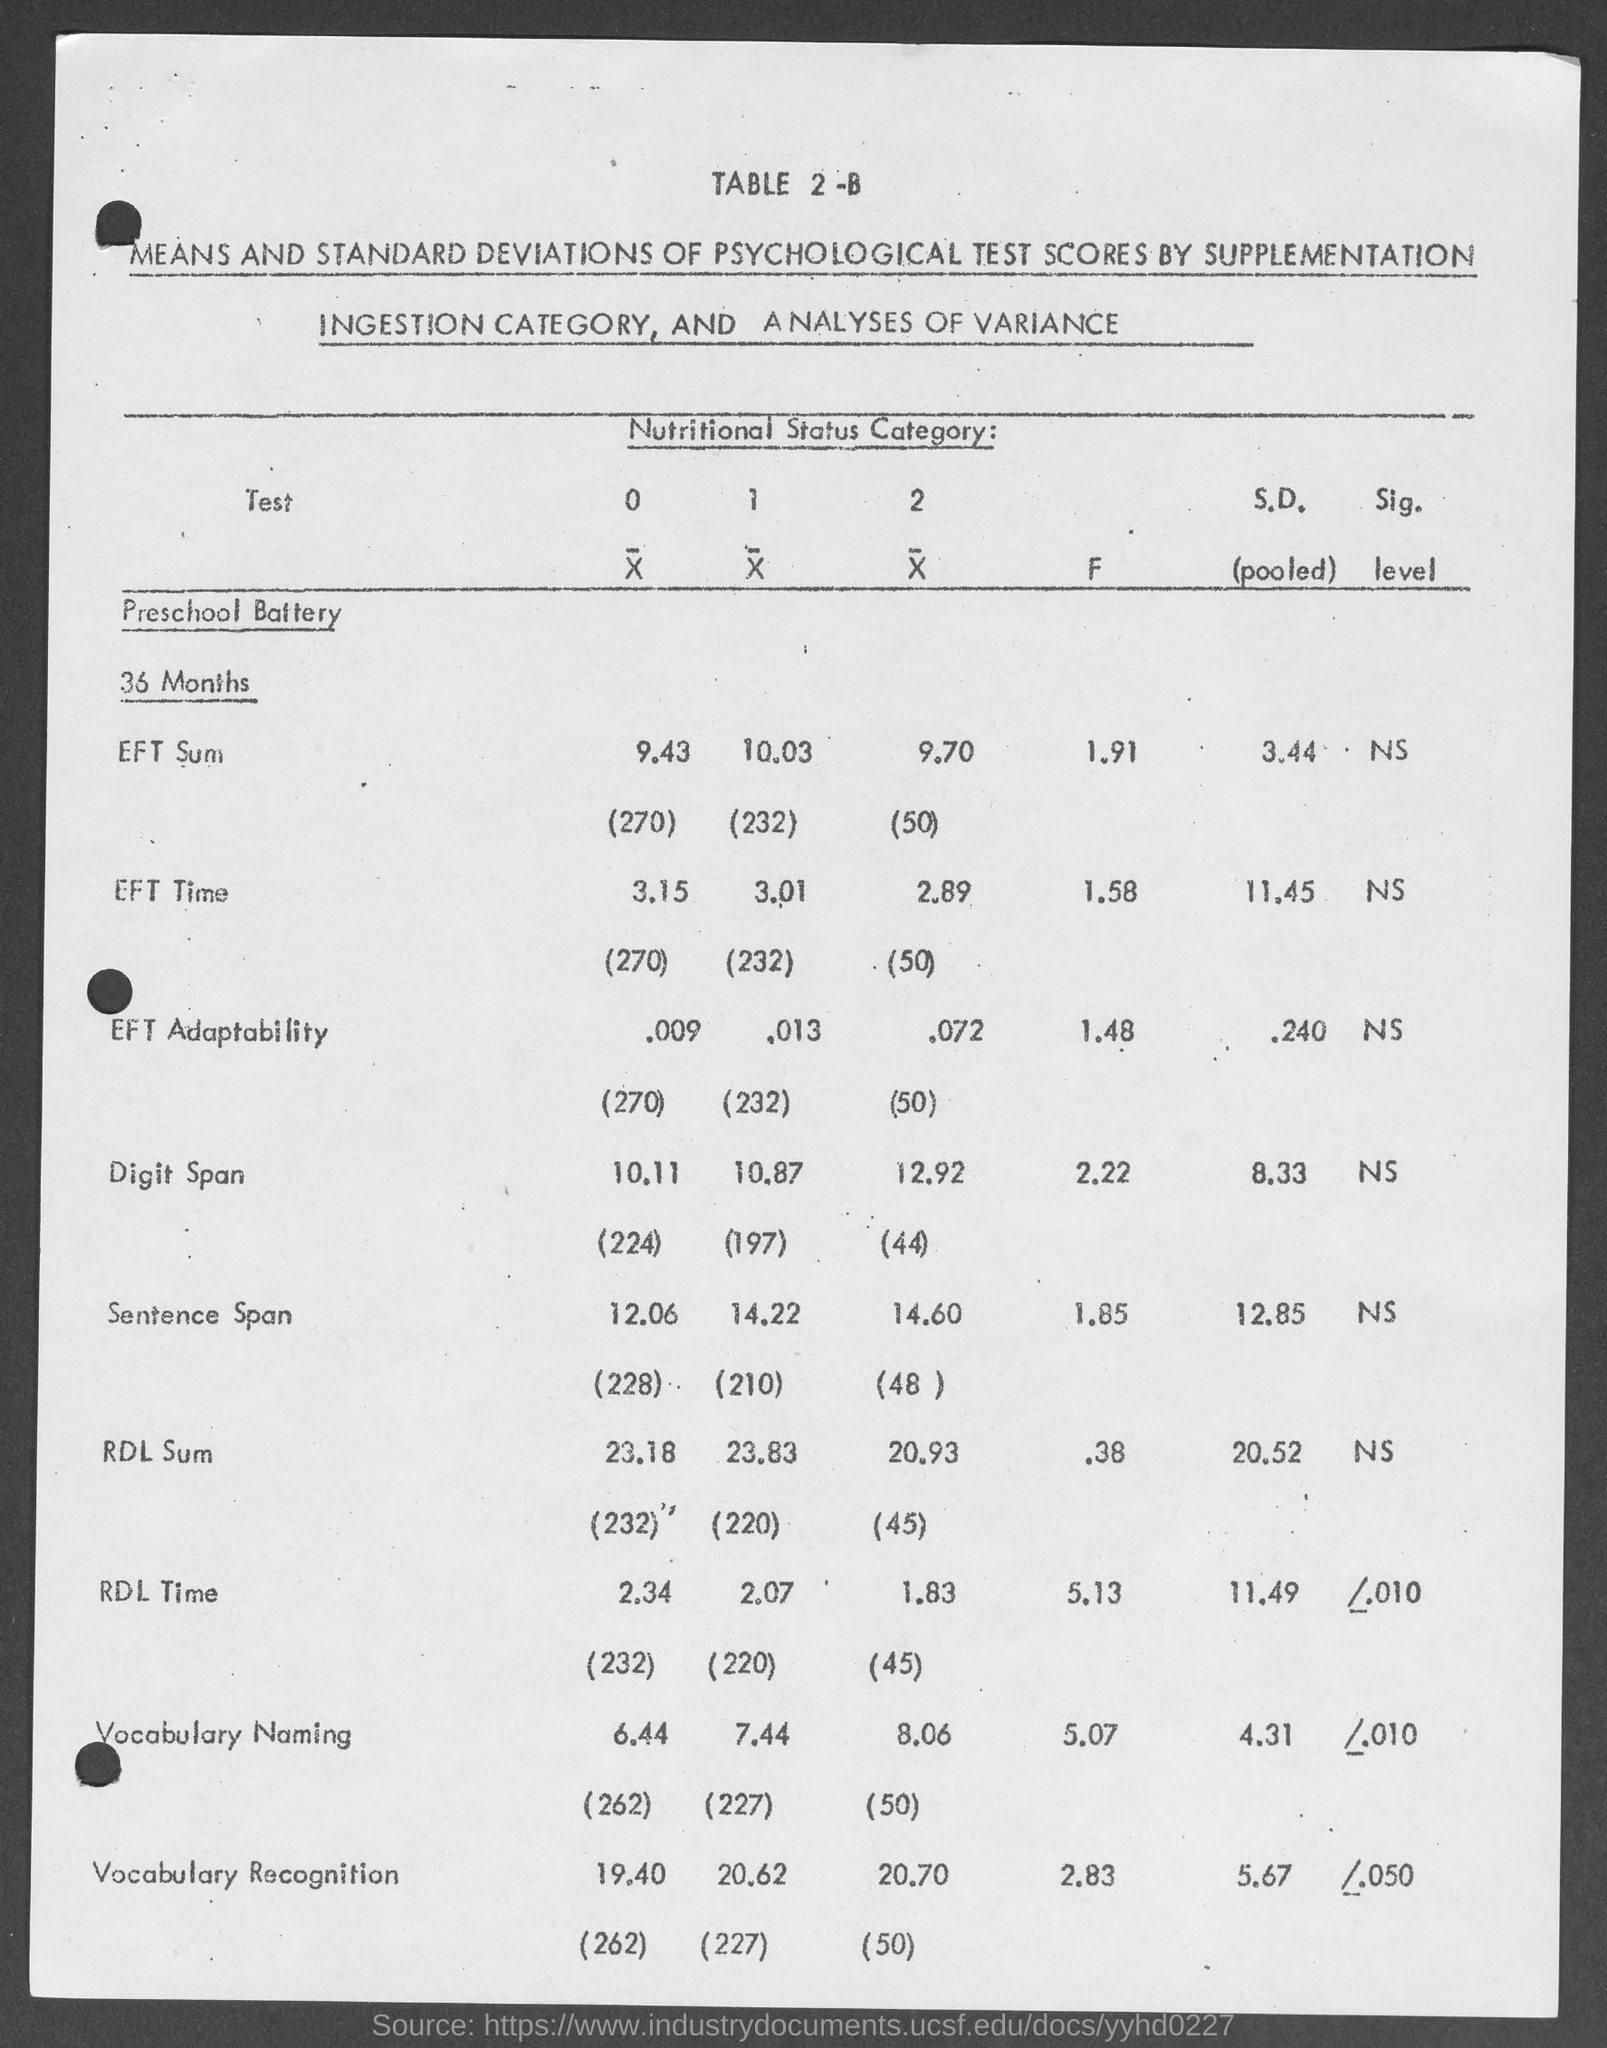What is the table no.?
Make the answer very short. 2-B. How many months are there?
Your answer should be compact. 36 MONTHS. What is the category about?
Give a very brief answer. Nutritional status. 